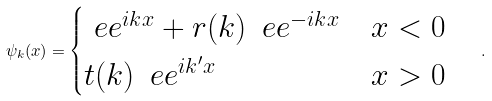Convert formula to latex. <formula><loc_0><loc_0><loc_500><loc_500>\psi _ { k } ( x ) = \begin{cases} \ e e ^ { i k x } + r ( k ) \, \ e e ^ { - i k x } & \text {$x < 0$} \\ t ( k ) \, \ e e ^ { i k ^ { \prime } x } & \text {$x > 0$} \end{cases} \quad .</formula> 